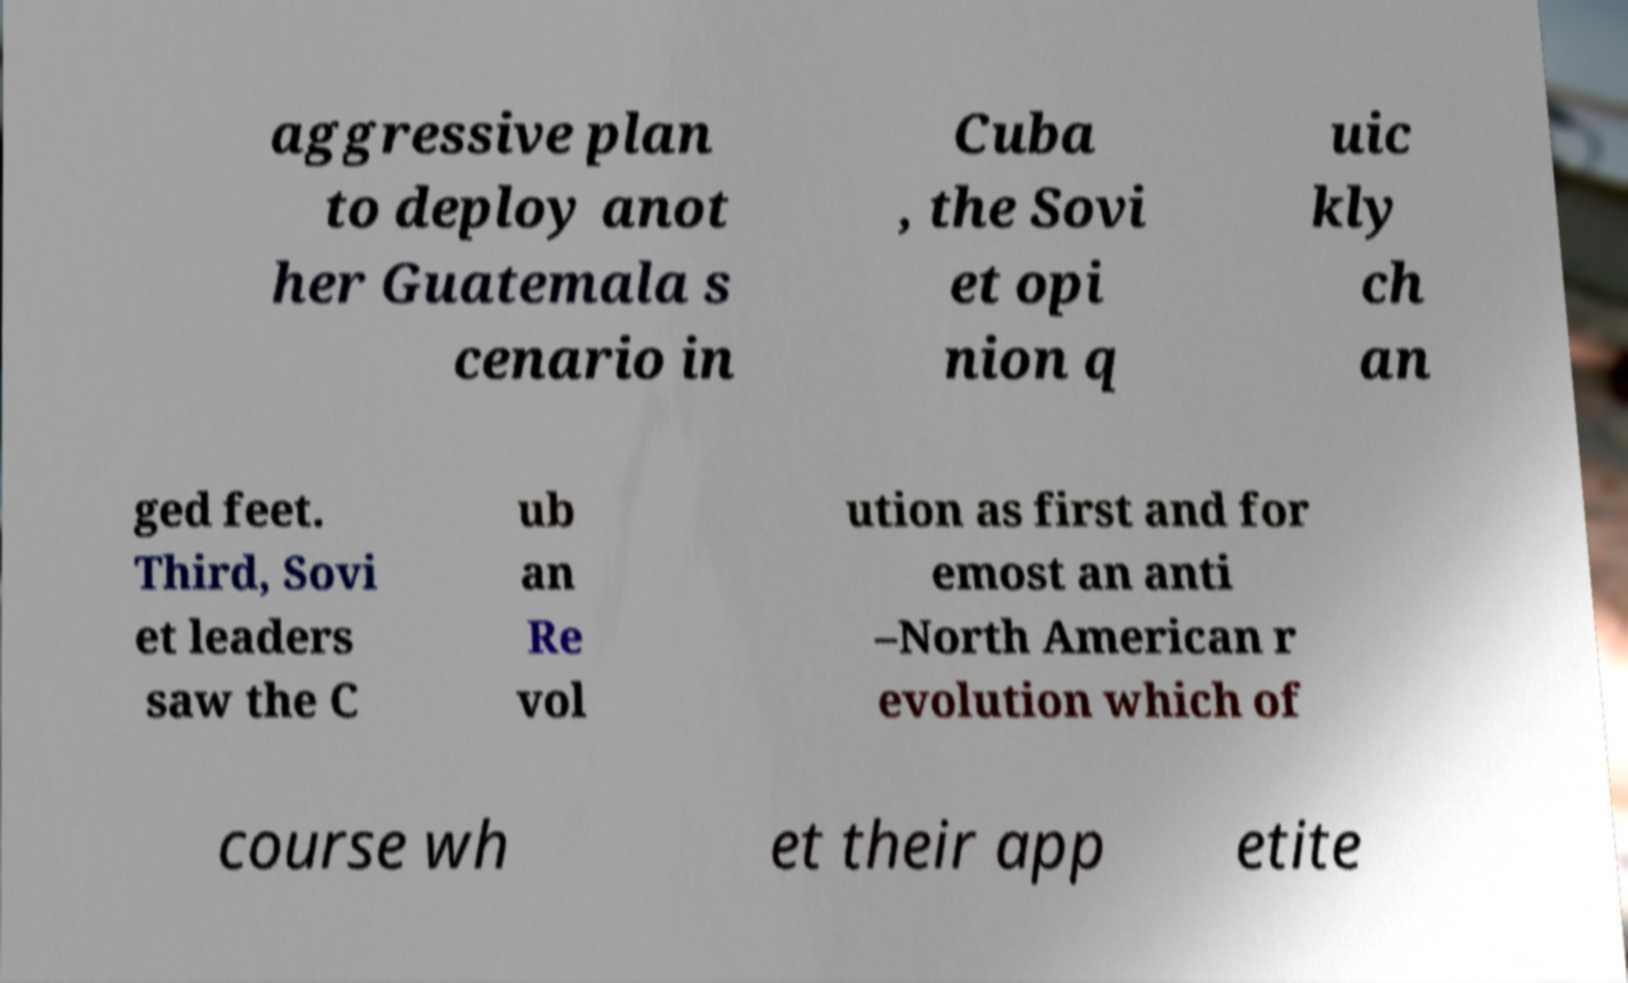Could you assist in decoding the text presented in this image and type it out clearly? aggressive plan to deploy anot her Guatemala s cenario in Cuba , the Sovi et opi nion q uic kly ch an ged feet. Third, Sovi et leaders saw the C ub an Re vol ution as first and for emost an anti –North American r evolution which of course wh et their app etite 